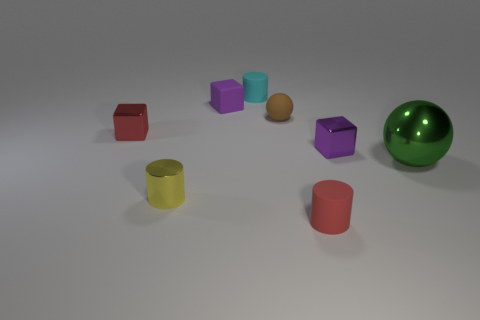Is the number of cyan cylinders that are in front of the cyan matte thing less than the number of balls that are to the left of the tiny rubber ball?
Your answer should be very brief. No. How many large spheres have the same material as the cyan cylinder?
Your answer should be compact. 0. There is a small metal block to the right of the small red object that is in front of the yellow object; is there a tiny ball that is behind it?
Ensure brevity in your answer.  Yes. The small purple object that is the same material as the big thing is what shape?
Provide a short and direct response. Cube. Is the number of red cylinders greater than the number of metal cubes?
Ensure brevity in your answer.  No. Does the yellow metallic thing have the same shape as the tiny red thing that is left of the brown object?
Offer a terse response. No. What is the material of the small ball?
Your response must be concise. Rubber. There is a shiny cube left of the red thing in front of the small metal block to the right of the small brown matte sphere; what color is it?
Give a very brief answer. Red. There is another tiny thing that is the same shape as the green metal object; what material is it?
Your response must be concise. Rubber. What number of purple things have the same size as the red rubber object?
Give a very brief answer. 2. 